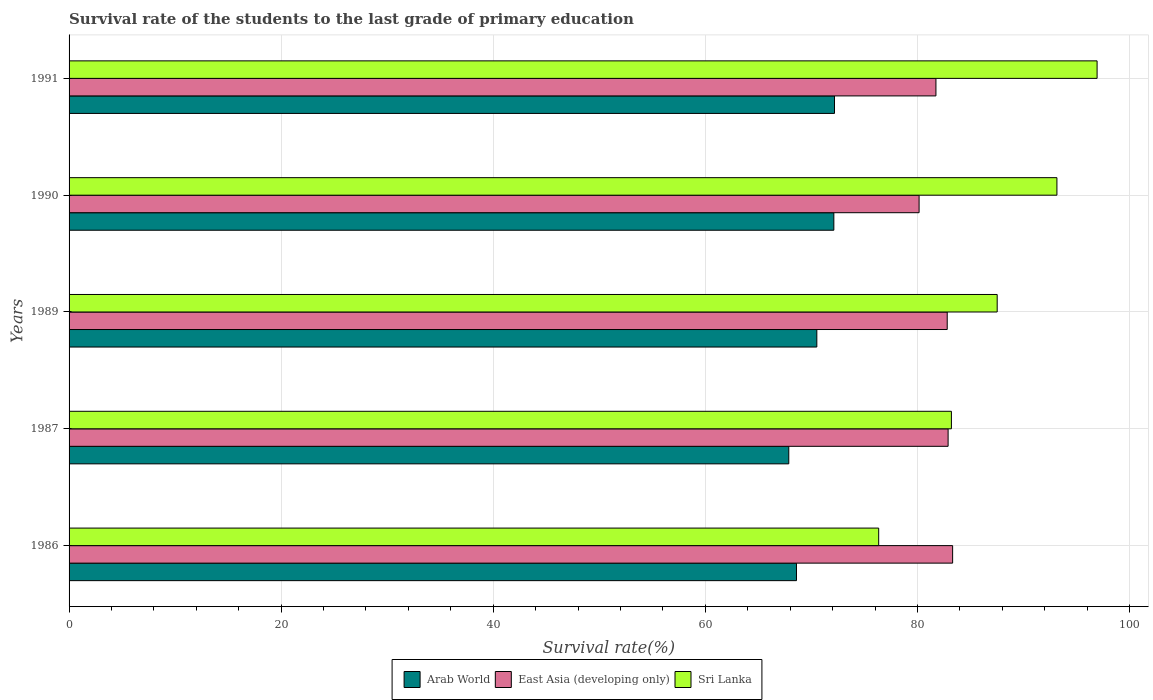How many groups of bars are there?
Offer a terse response. 5. How many bars are there on the 1st tick from the top?
Make the answer very short. 3. How many bars are there on the 5th tick from the bottom?
Make the answer very short. 3. In how many cases, is the number of bars for a given year not equal to the number of legend labels?
Make the answer very short. 0. What is the survival rate of the students in Arab World in 1987?
Provide a short and direct response. 67.87. Across all years, what is the maximum survival rate of the students in Sri Lanka?
Offer a terse response. 96.94. Across all years, what is the minimum survival rate of the students in East Asia (developing only)?
Offer a very short reply. 80.16. In which year was the survival rate of the students in Sri Lanka minimum?
Keep it short and to the point. 1986. What is the total survival rate of the students in East Asia (developing only) in the graph?
Keep it short and to the point. 410.93. What is the difference between the survival rate of the students in East Asia (developing only) in 1989 and that in 1991?
Your response must be concise. 1.06. What is the difference between the survival rate of the students in Arab World in 1991 and the survival rate of the students in Sri Lanka in 1989?
Provide a succinct answer. -15.34. What is the average survival rate of the students in Sri Lanka per year?
Make the answer very short. 87.44. In the year 1990, what is the difference between the survival rate of the students in Arab World and survival rate of the students in East Asia (developing only)?
Offer a terse response. -8.04. What is the ratio of the survival rate of the students in Arab World in 1986 to that in 1989?
Keep it short and to the point. 0.97. Is the survival rate of the students in Arab World in 1986 less than that in 1990?
Offer a very short reply. Yes. What is the difference between the highest and the second highest survival rate of the students in East Asia (developing only)?
Ensure brevity in your answer.  0.43. What is the difference between the highest and the lowest survival rate of the students in Arab World?
Give a very brief answer. 4.31. What does the 2nd bar from the top in 1989 represents?
Provide a succinct answer. East Asia (developing only). What does the 3rd bar from the bottom in 1991 represents?
Make the answer very short. Sri Lanka. Is it the case that in every year, the sum of the survival rate of the students in Arab World and survival rate of the students in Sri Lanka is greater than the survival rate of the students in East Asia (developing only)?
Your answer should be compact. Yes. Are the values on the major ticks of X-axis written in scientific E-notation?
Your answer should be very brief. No. How many legend labels are there?
Your response must be concise. 3. What is the title of the graph?
Give a very brief answer. Survival rate of the students to the last grade of primary education. Does "Slovak Republic" appear as one of the legend labels in the graph?
Provide a succinct answer. No. What is the label or title of the X-axis?
Provide a succinct answer. Survival rate(%). What is the label or title of the Y-axis?
Your response must be concise. Years. What is the Survival rate(%) of Arab World in 1986?
Make the answer very short. 68.6. What is the Survival rate(%) in East Asia (developing only) in 1986?
Your answer should be compact. 83.32. What is the Survival rate(%) in Sri Lanka in 1986?
Make the answer very short. 76.35. What is the Survival rate(%) in Arab World in 1987?
Offer a very short reply. 67.87. What is the Survival rate(%) in East Asia (developing only) in 1987?
Your response must be concise. 82.89. What is the Survival rate(%) of Sri Lanka in 1987?
Provide a short and direct response. 83.21. What is the Survival rate(%) in Arab World in 1989?
Keep it short and to the point. 70.52. What is the Survival rate(%) of East Asia (developing only) in 1989?
Give a very brief answer. 82.81. What is the Survival rate(%) in Sri Lanka in 1989?
Keep it short and to the point. 87.52. What is the Survival rate(%) in Arab World in 1990?
Your answer should be very brief. 72.12. What is the Survival rate(%) in East Asia (developing only) in 1990?
Ensure brevity in your answer.  80.16. What is the Survival rate(%) of Sri Lanka in 1990?
Keep it short and to the point. 93.16. What is the Survival rate(%) of Arab World in 1991?
Offer a terse response. 72.18. What is the Survival rate(%) in East Asia (developing only) in 1991?
Provide a short and direct response. 81.75. What is the Survival rate(%) in Sri Lanka in 1991?
Give a very brief answer. 96.94. Across all years, what is the maximum Survival rate(%) of Arab World?
Provide a short and direct response. 72.18. Across all years, what is the maximum Survival rate(%) of East Asia (developing only)?
Offer a very short reply. 83.32. Across all years, what is the maximum Survival rate(%) of Sri Lanka?
Keep it short and to the point. 96.94. Across all years, what is the minimum Survival rate(%) of Arab World?
Make the answer very short. 67.87. Across all years, what is the minimum Survival rate(%) in East Asia (developing only)?
Make the answer very short. 80.16. Across all years, what is the minimum Survival rate(%) of Sri Lanka?
Offer a terse response. 76.35. What is the total Survival rate(%) in Arab World in the graph?
Give a very brief answer. 351.28. What is the total Survival rate(%) in East Asia (developing only) in the graph?
Your answer should be very brief. 410.93. What is the total Survival rate(%) of Sri Lanka in the graph?
Give a very brief answer. 437.18. What is the difference between the Survival rate(%) of Arab World in 1986 and that in 1987?
Provide a short and direct response. 0.73. What is the difference between the Survival rate(%) in East Asia (developing only) in 1986 and that in 1987?
Offer a terse response. 0.43. What is the difference between the Survival rate(%) in Sri Lanka in 1986 and that in 1987?
Provide a succinct answer. -6.86. What is the difference between the Survival rate(%) in Arab World in 1986 and that in 1989?
Keep it short and to the point. -1.92. What is the difference between the Survival rate(%) of East Asia (developing only) in 1986 and that in 1989?
Your response must be concise. 0.51. What is the difference between the Survival rate(%) in Sri Lanka in 1986 and that in 1989?
Provide a succinct answer. -11.17. What is the difference between the Survival rate(%) in Arab World in 1986 and that in 1990?
Your answer should be compact. -3.52. What is the difference between the Survival rate(%) of East Asia (developing only) in 1986 and that in 1990?
Offer a very short reply. 3.16. What is the difference between the Survival rate(%) of Sri Lanka in 1986 and that in 1990?
Your response must be concise. -16.81. What is the difference between the Survival rate(%) of Arab World in 1986 and that in 1991?
Keep it short and to the point. -3.59. What is the difference between the Survival rate(%) in East Asia (developing only) in 1986 and that in 1991?
Ensure brevity in your answer.  1.57. What is the difference between the Survival rate(%) in Sri Lanka in 1986 and that in 1991?
Give a very brief answer. -20.6. What is the difference between the Survival rate(%) of Arab World in 1987 and that in 1989?
Provide a short and direct response. -2.64. What is the difference between the Survival rate(%) in East Asia (developing only) in 1987 and that in 1989?
Your answer should be very brief. 0.08. What is the difference between the Survival rate(%) of Sri Lanka in 1987 and that in 1989?
Your answer should be very brief. -4.32. What is the difference between the Survival rate(%) in Arab World in 1987 and that in 1990?
Provide a succinct answer. -4.25. What is the difference between the Survival rate(%) in East Asia (developing only) in 1987 and that in 1990?
Your response must be concise. 2.74. What is the difference between the Survival rate(%) in Sri Lanka in 1987 and that in 1990?
Provide a short and direct response. -9.95. What is the difference between the Survival rate(%) of Arab World in 1987 and that in 1991?
Keep it short and to the point. -4.31. What is the difference between the Survival rate(%) in East Asia (developing only) in 1987 and that in 1991?
Your answer should be very brief. 1.15. What is the difference between the Survival rate(%) of Sri Lanka in 1987 and that in 1991?
Your answer should be compact. -13.74. What is the difference between the Survival rate(%) of Arab World in 1989 and that in 1990?
Your answer should be very brief. -1.6. What is the difference between the Survival rate(%) of East Asia (developing only) in 1989 and that in 1990?
Provide a short and direct response. 2.65. What is the difference between the Survival rate(%) in Sri Lanka in 1989 and that in 1990?
Your response must be concise. -5.63. What is the difference between the Survival rate(%) of Arab World in 1989 and that in 1991?
Make the answer very short. -1.67. What is the difference between the Survival rate(%) in East Asia (developing only) in 1989 and that in 1991?
Make the answer very short. 1.06. What is the difference between the Survival rate(%) of Sri Lanka in 1989 and that in 1991?
Offer a very short reply. -9.42. What is the difference between the Survival rate(%) of Arab World in 1990 and that in 1991?
Keep it short and to the point. -0.06. What is the difference between the Survival rate(%) of East Asia (developing only) in 1990 and that in 1991?
Make the answer very short. -1.59. What is the difference between the Survival rate(%) in Sri Lanka in 1990 and that in 1991?
Give a very brief answer. -3.79. What is the difference between the Survival rate(%) in Arab World in 1986 and the Survival rate(%) in East Asia (developing only) in 1987?
Offer a terse response. -14.3. What is the difference between the Survival rate(%) of Arab World in 1986 and the Survival rate(%) of Sri Lanka in 1987?
Ensure brevity in your answer.  -14.61. What is the difference between the Survival rate(%) of East Asia (developing only) in 1986 and the Survival rate(%) of Sri Lanka in 1987?
Your response must be concise. 0.12. What is the difference between the Survival rate(%) of Arab World in 1986 and the Survival rate(%) of East Asia (developing only) in 1989?
Your answer should be compact. -14.21. What is the difference between the Survival rate(%) in Arab World in 1986 and the Survival rate(%) in Sri Lanka in 1989?
Keep it short and to the point. -18.93. What is the difference between the Survival rate(%) in East Asia (developing only) in 1986 and the Survival rate(%) in Sri Lanka in 1989?
Your response must be concise. -4.2. What is the difference between the Survival rate(%) of Arab World in 1986 and the Survival rate(%) of East Asia (developing only) in 1990?
Keep it short and to the point. -11.56. What is the difference between the Survival rate(%) in Arab World in 1986 and the Survival rate(%) in Sri Lanka in 1990?
Ensure brevity in your answer.  -24.56. What is the difference between the Survival rate(%) in East Asia (developing only) in 1986 and the Survival rate(%) in Sri Lanka in 1990?
Provide a short and direct response. -9.84. What is the difference between the Survival rate(%) of Arab World in 1986 and the Survival rate(%) of East Asia (developing only) in 1991?
Offer a terse response. -13.15. What is the difference between the Survival rate(%) of Arab World in 1986 and the Survival rate(%) of Sri Lanka in 1991?
Provide a short and direct response. -28.35. What is the difference between the Survival rate(%) of East Asia (developing only) in 1986 and the Survival rate(%) of Sri Lanka in 1991?
Your answer should be compact. -13.62. What is the difference between the Survival rate(%) of Arab World in 1987 and the Survival rate(%) of East Asia (developing only) in 1989?
Give a very brief answer. -14.94. What is the difference between the Survival rate(%) in Arab World in 1987 and the Survival rate(%) in Sri Lanka in 1989?
Provide a succinct answer. -19.65. What is the difference between the Survival rate(%) in East Asia (developing only) in 1987 and the Survival rate(%) in Sri Lanka in 1989?
Your answer should be very brief. -4.63. What is the difference between the Survival rate(%) of Arab World in 1987 and the Survival rate(%) of East Asia (developing only) in 1990?
Make the answer very short. -12.29. What is the difference between the Survival rate(%) of Arab World in 1987 and the Survival rate(%) of Sri Lanka in 1990?
Ensure brevity in your answer.  -25.29. What is the difference between the Survival rate(%) in East Asia (developing only) in 1987 and the Survival rate(%) in Sri Lanka in 1990?
Offer a very short reply. -10.26. What is the difference between the Survival rate(%) of Arab World in 1987 and the Survival rate(%) of East Asia (developing only) in 1991?
Give a very brief answer. -13.88. What is the difference between the Survival rate(%) in Arab World in 1987 and the Survival rate(%) in Sri Lanka in 1991?
Ensure brevity in your answer.  -29.07. What is the difference between the Survival rate(%) in East Asia (developing only) in 1987 and the Survival rate(%) in Sri Lanka in 1991?
Provide a short and direct response. -14.05. What is the difference between the Survival rate(%) of Arab World in 1989 and the Survival rate(%) of East Asia (developing only) in 1990?
Your answer should be very brief. -9.64. What is the difference between the Survival rate(%) in Arab World in 1989 and the Survival rate(%) in Sri Lanka in 1990?
Provide a succinct answer. -22.64. What is the difference between the Survival rate(%) in East Asia (developing only) in 1989 and the Survival rate(%) in Sri Lanka in 1990?
Your answer should be very brief. -10.35. What is the difference between the Survival rate(%) in Arab World in 1989 and the Survival rate(%) in East Asia (developing only) in 1991?
Offer a terse response. -11.23. What is the difference between the Survival rate(%) of Arab World in 1989 and the Survival rate(%) of Sri Lanka in 1991?
Provide a succinct answer. -26.43. What is the difference between the Survival rate(%) in East Asia (developing only) in 1989 and the Survival rate(%) in Sri Lanka in 1991?
Your answer should be very brief. -14.13. What is the difference between the Survival rate(%) in Arab World in 1990 and the Survival rate(%) in East Asia (developing only) in 1991?
Make the answer very short. -9.63. What is the difference between the Survival rate(%) of Arab World in 1990 and the Survival rate(%) of Sri Lanka in 1991?
Offer a terse response. -24.83. What is the difference between the Survival rate(%) of East Asia (developing only) in 1990 and the Survival rate(%) of Sri Lanka in 1991?
Offer a very short reply. -16.79. What is the average Survival rate(%) of Arab World per year?
Ensure brevity in your answer.  70.26. What is the average Survival rate(%) in East Asia (developing only) per year?
Offer a very short reply. 82.19. What is the average Survival rate(%) of Sri Lanka per year?
Ensure brevity in your answer.  87.44. In the year 1986, what is the difference between the Survival rate(%) in Arab World and Survival rate(%) in East Asia (developing only)?
Ensure brevity in your answer.  -14.72. In the year 1986, what is the difference between the Survival rate(%) in Arab World and Survival rate(%) in Sri Lanka?
Offer a terse response. -7.75. In the year 1986, what is the difference between the Survival rate(%) in East Asia (developing only) and Survival rate(%) in Sri Lanka?
Your answer should be compact. 6.97. In the year 1987, what is the difference between the Survival rate(%) of Arab World and Survival rate(%) of East Asia (developing only)?
Give a very brief answer. -15.02. In the year 1987, what is the difference between the Survival rate(%) in Arab World and Survival rate(%) in Sri Lanka?
Your answer should be very brief. -15.34. In the year 1987, what is the difference between the Survival rate(%) in East Asia (developing only) and Survival rate(%) in Sri Lanka?
Make the answer very short. -0.31. In the year 1989, what is the difference between the Survival rate(%) in Arab World and Survival rate(%) in East Asia (developing only)?
Provide a succinct answer. -12.3. In the year 1989, what is the difference between the Survival rate(%) in Arab World and Survival rate(%) in Sri Lanka?
Offer a very short reply. -17.01. In the year 1989, what is the difference between the Survival rate(%) in East Asia (developing only) and Survival rate(%) in Sri Lanka?
Provide a short and direct response. -4.71. In the year 1990, what is the difference between the Survival rate(%) in Arab World and Survival rate(%) in East Asia (developing only)?
Ensure brevity in your answer.  -8.04. In the year 1990, what is the difference between the Survival rate(%) in Arab World and Survival rate(%) in Sri Lanka?
Provide a short and direct response. -21.04. In the year 1990, what is the difference between the Survival rate(%) of East Asia (developing only) and Survival rate(%) of Sri Lanka?
Provide a succinct answer. -13. In the year 1991, what is the difference between the Survival rate(%) in Arab World and Survival rate(%) in East Asia (developing only)?
Your response must be concise. -9.57. In the year 1991, what is the difference between the Survival rate(%) in Arab World and Survival rate(%) in Sri Lanka?
Ensure brevity in your answer.  -24.76. In the year 1991, what is the difference between the Survival rate(%) of East Asia (developing only) and Survival rate(%) of Sri Lanka?
Your answer should be very brief. -15.2. What is the ratio of the Survival rate(%) in Arab World in 1986 to that in 1987?
Offer a very short reply. 1.01. What is the ratio of the Survival rate(%) in Sri Lanka in 1986 to that in 1987?
Your answer should be very brief. 0.92. What is the ratio of the Survival rate(%) in Arab World in 1986 to that in 1989?
Ensure brevity in your answer.  0.97. What is the ratio of the Survival rate(%) of East Asia (developing only) in 1986 to that in 1989?
Your response must be concise. 1.01. What is the ratio of the Survival rate(%) in Sri Lanka in 1986 to that in 1989?
Give a very brief answer. 0.87. What is the ratio of the Survival rate(%) of Arab World in 1986 to that in 1990?
Keep it short and to the point. 0.95. What is the ratio of the Survival rate(%) of East Asia (developing only) in 1986 to that in 1990?
Ensure brevity in your answer.  1.04. What is the ratio of the Survival rate(%) in Sri Lanka in 1986 to that in 1990?
Provide a short and direct response. 0.82. What is the ratio of the Survival rate(%) in Arab World in 1986 to that in 1991?
Give a very brief answer. 0.95. What is the ratio of the Survival rate(%) of East Asia (developing only) in 1986 to that in 1991?
Provide a short and direct response. 1.02. What is the ratio of the Survival rate(%) of Sri Lanka in 1986 to that in 1991?
Your response must be concise. 0.79. What is the ratio of the Survival rate(%) in Arab World in 1987 to that in 1989?
Provide a succinct answer. 0.96. What is the ratio of the Survival rate(%) of Sri Lanka in 1987 to that in 1989?
Provide a short and direct response. 0.95. What is the ratio of the Survival rate(%) of Arab World in 1987 to that in 1990?
Your answer should be compact. 0.94. What is the ratio of the Survival rate(%) of East Asia (developing only) in 1987 to that in 1990?
Offer a terse response. 1.03. What is the ratio of the Survival rate(%) in Sri Lanka in 1987 to that in 1990?
Make the answer very short. 0.89. What is the ratio of the Survival rate(%) in Arab World in 1987 to that in 1991?
Offer a very short reply. 0.94. What is the ratio of the Survival rate(%) of Sri Lanka in 1987 to that in 1991?
Provide a short and direct response. 0.86. What is the ratio of the Survival rate(%) in Arab World in 1989 to that in 1990?
Offer a very short reply. 0.98. What is the ratio of the Survival rate(%) of East Asia (developing only) in 1989 to that in 1990?
Give a very brief answer. 1.03. What is the ratio of the Survival rate(%) of Sri Lanka in 1989 to that in 1990?
Your answer should be compact. 0.94. What is the ratio of the Survival rate(%) in Arab World in 1989 to that in 1991?
Your answer should be compact. 0.98. What is the ratio of the Survival rate(%) in East Asia (developing only) in 1989 to that in 1991?
Provide a succinct answer. 1.01. What is the ratio of the Survival rate(%) of Sri Lanka in 1989 to that in 1991?
Your answer should be very brief. 0.9. What is the ratio of the Survival rate(%) in Arab World in 1990 to that in 1991?
Your answer should be very brief. 1. What is the ratio of the Survival rate(%) in East Asia (developing only) in 1990 to that in 1991?
Give a very brief answer. 0.98. What is the ratio of the Survival rate(%) of Sri Lanka in 1990 to that in 1991?
Provide a short and direct response. 0.96. What is the difference between the highest and the second highest Survival rate(%) of Arab World?
Your answer should be very brief. 0.06. What is the difference between the highest and the second highest Survival rate(%) in East Asia (developing only)?
Offer a terse response. 0.43. What is the difference between the highest and the second highest Survival rate(%) in Sri Lanka?
Provide a succinct answer. 3.79. What is the difference between the highest and the lowest Survival rate(%) in Arab World?
Offer a very short reply. 4.31. What is the difference between the highest and the lowest Survival rate(%) in East Asia (developing only)?
Provide a short and direct response. 3.16. What is the difference between the highest and the lowest Survival rate(%) in Sri Lanka?
Ensure brevity in your answer.  20.6. 